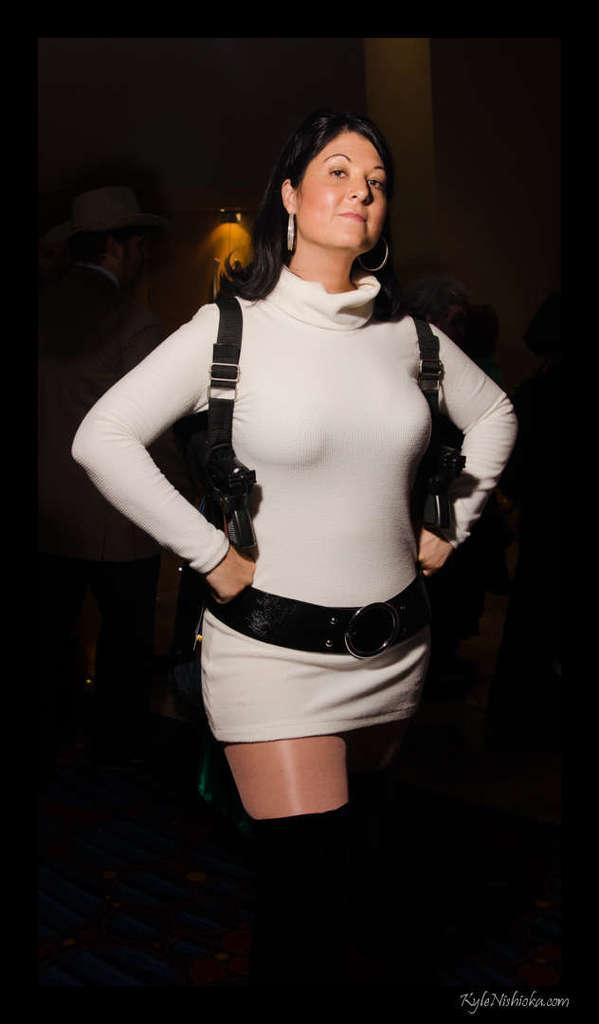Please provide a concise description of this image. In this image, we can see a woman is standing and watching. Background we can see people and light. Here we can see black color borders in the image. On the right side bottom corner, there is a watermark in the image. 